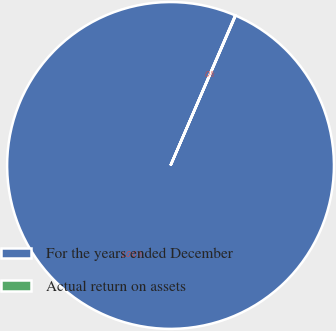Convert chart to OTSL. <chart><loc_0><loc_0><loc_500><loc_500><pie_chart><fcel>For the years ended December<fcel>Actual return on assets<nl><fcel>99.96%<fcel>0.04%<nl></chart> 